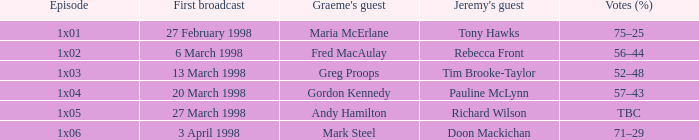What is Votes (%), when Episode is "1x03"? 52–48. 